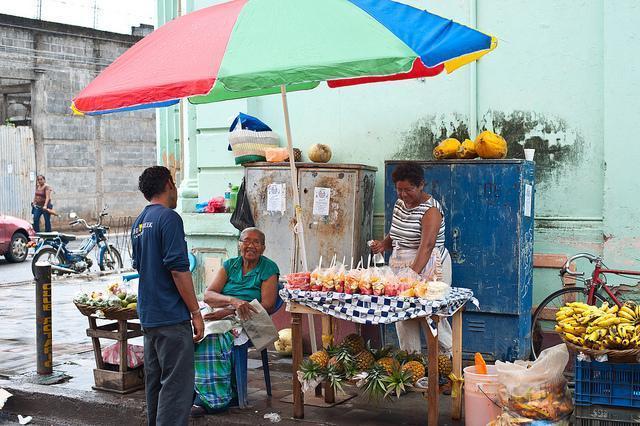How many people can you see?
Give a very brief answer. 3. How many umbrellas can you see?
Give a very brief answer. 1. How many trains have a number on the front?
Give a very brief answer. 0. 